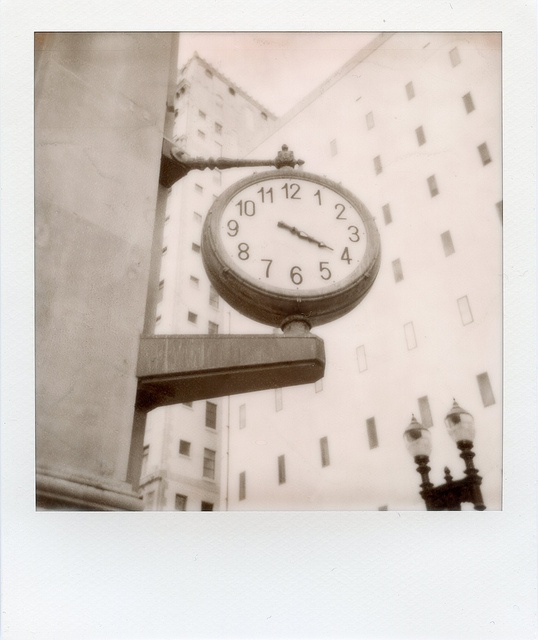Describe the objects in this image and their specific colors. I can see a clock in white, lightgray, darkgray, and maroon tones in this image. 